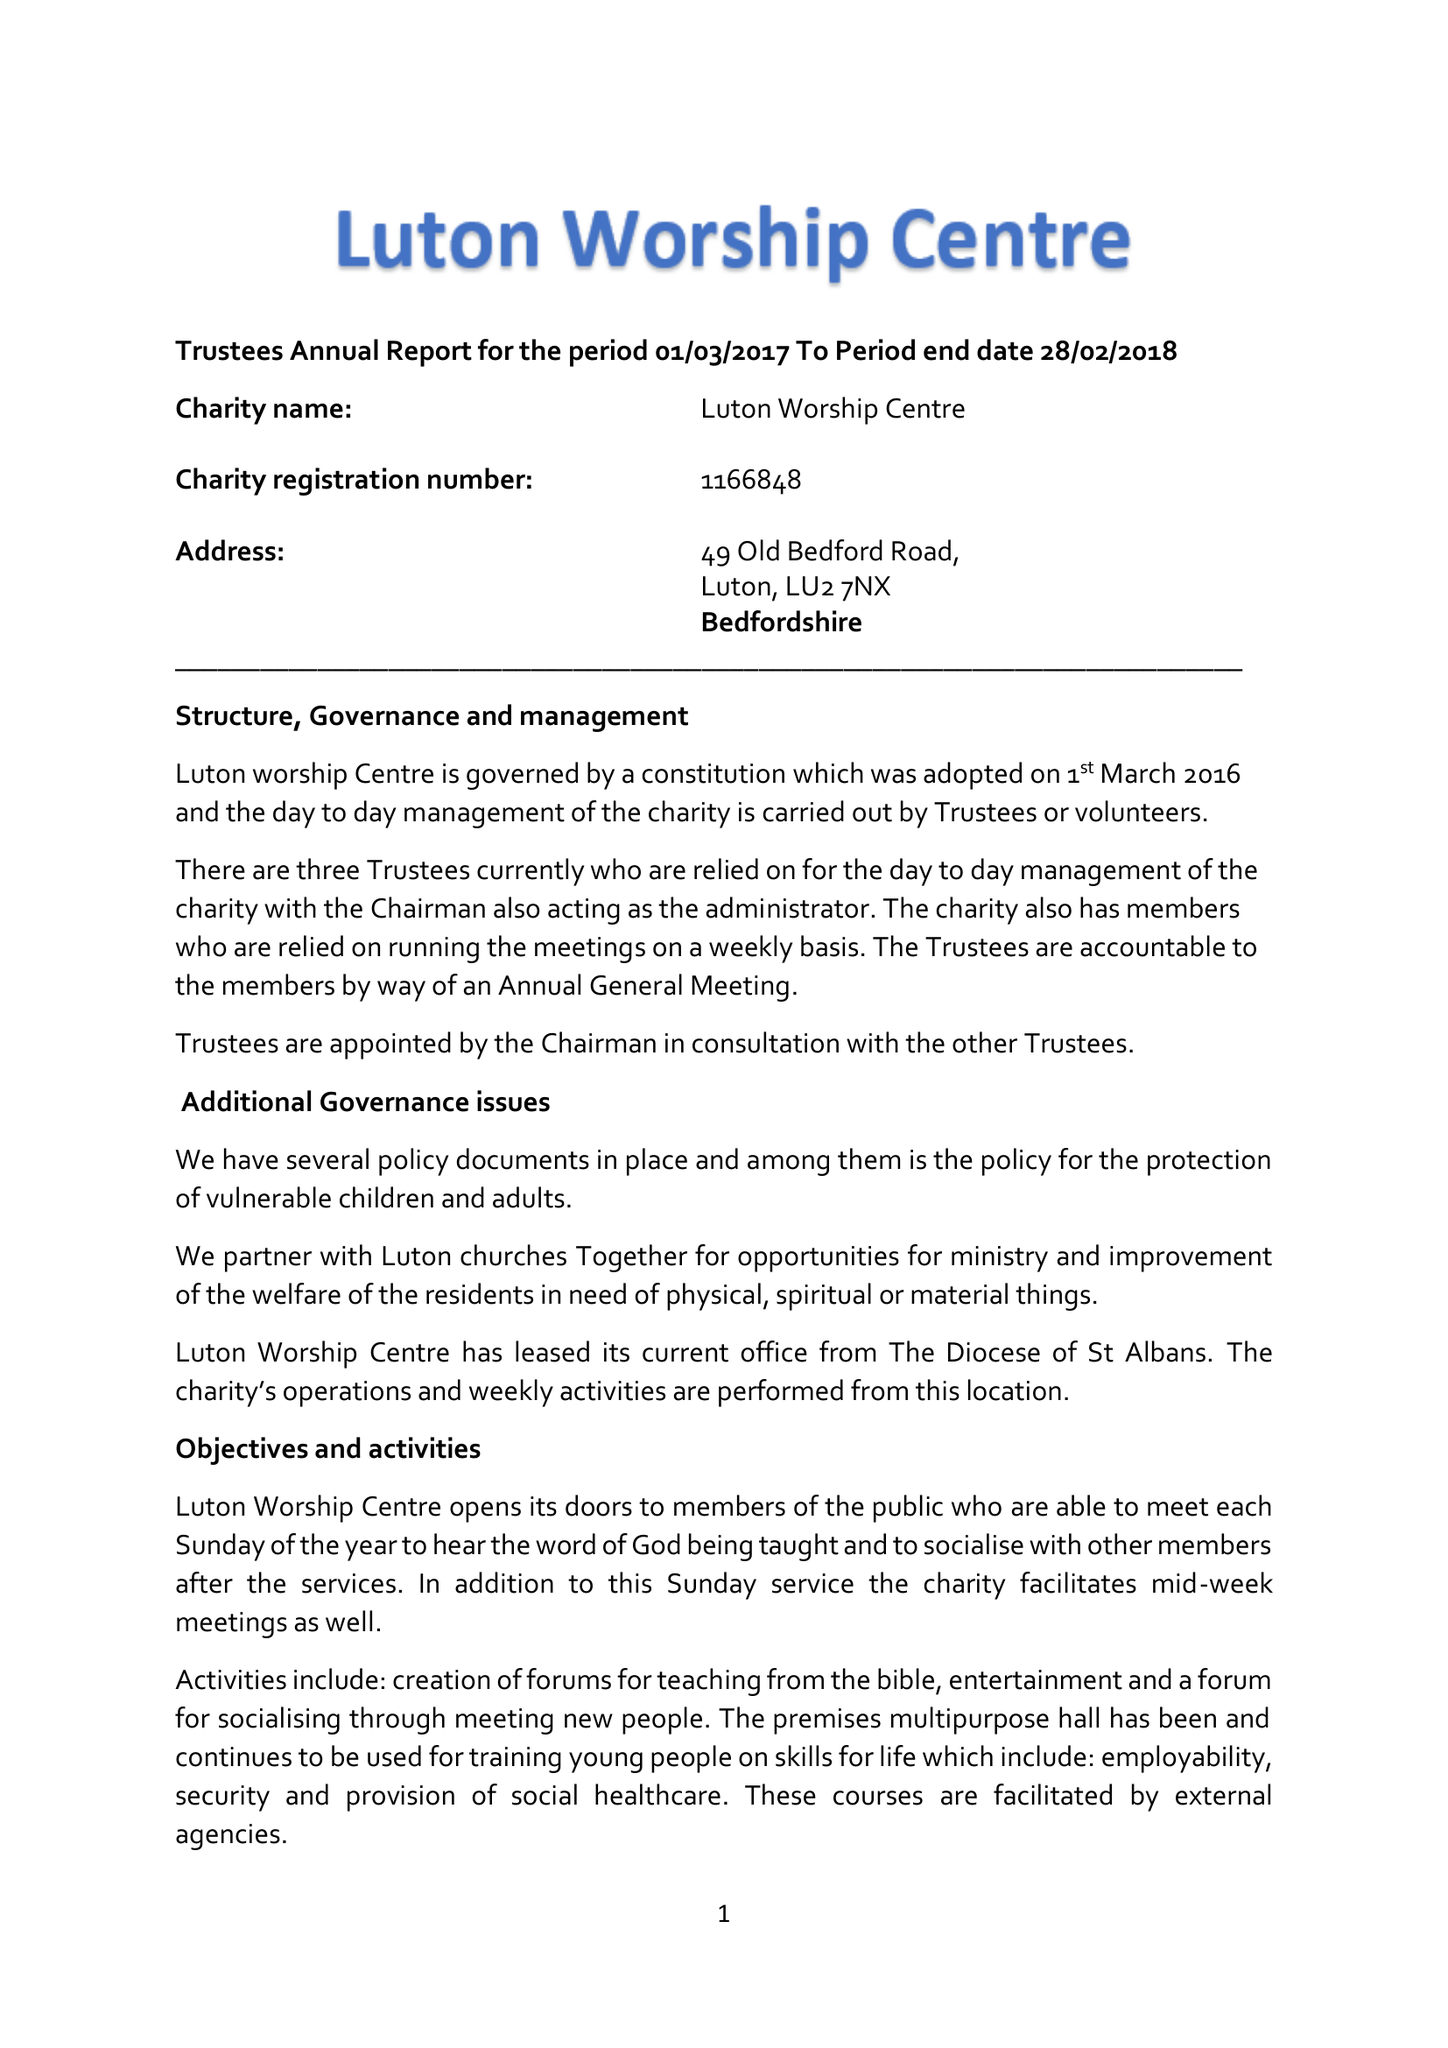What is the value for the spending_annually_in_british_pounds?
Answer the question using a single word or phrase. 20845.00 